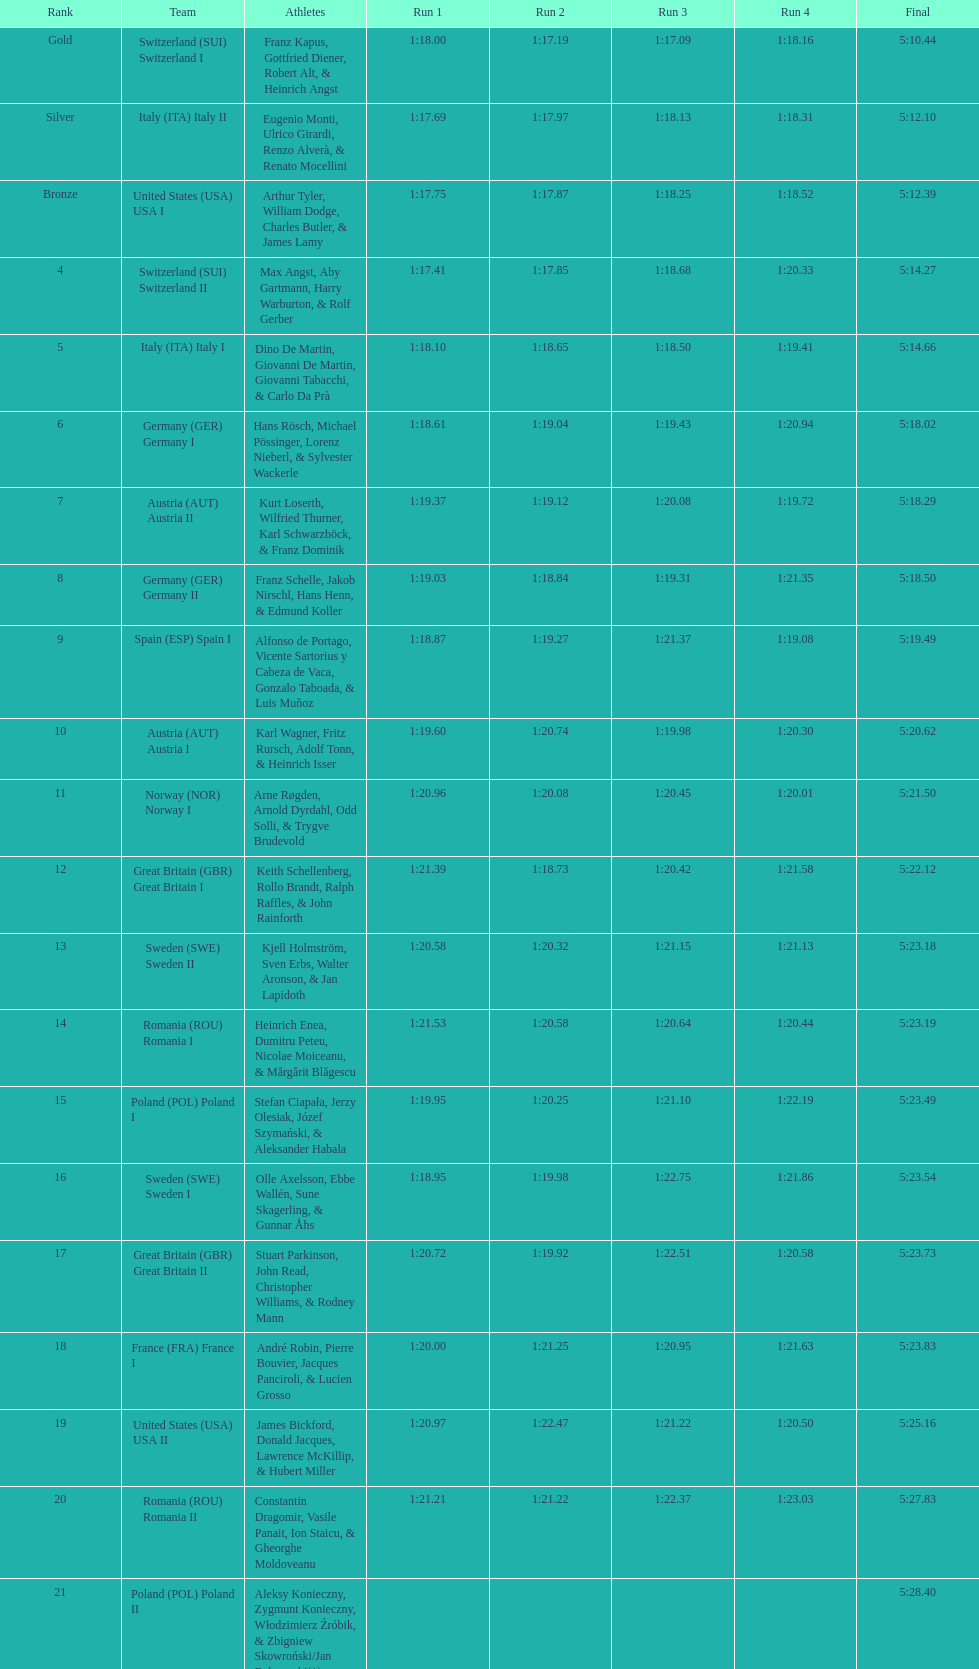After italy (ita) italy i, what team comes next? Germany I. 